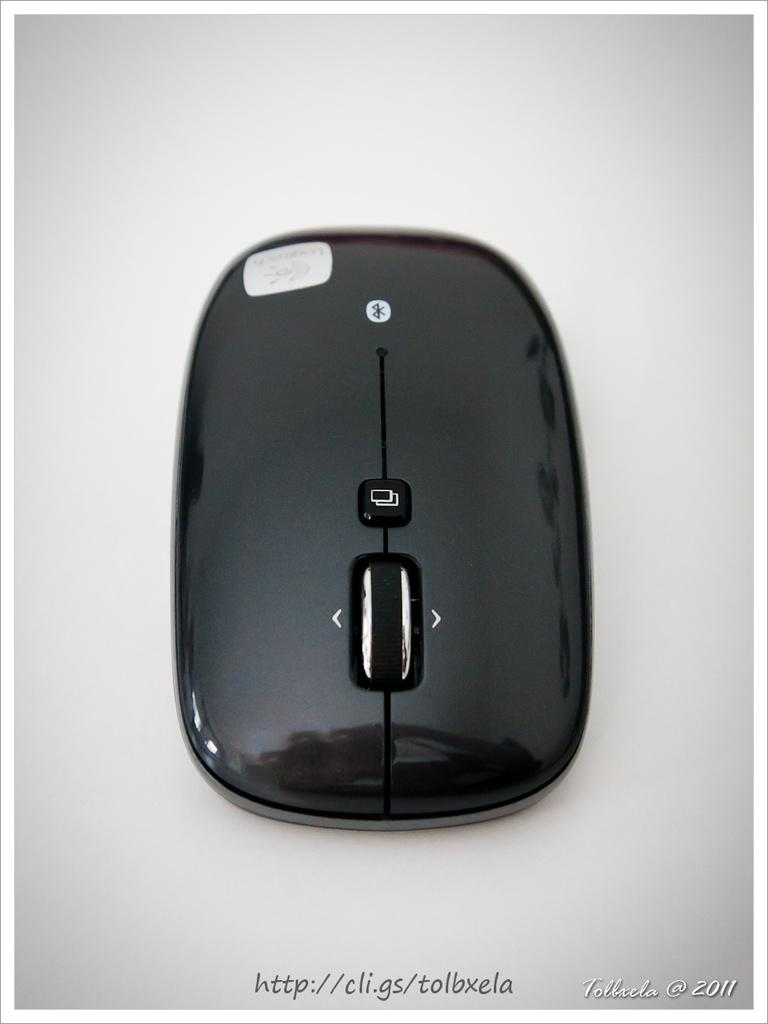<image>
Create a compact narrative representing the image presented. a mouse with several buttons and a scroll function was from 2011 